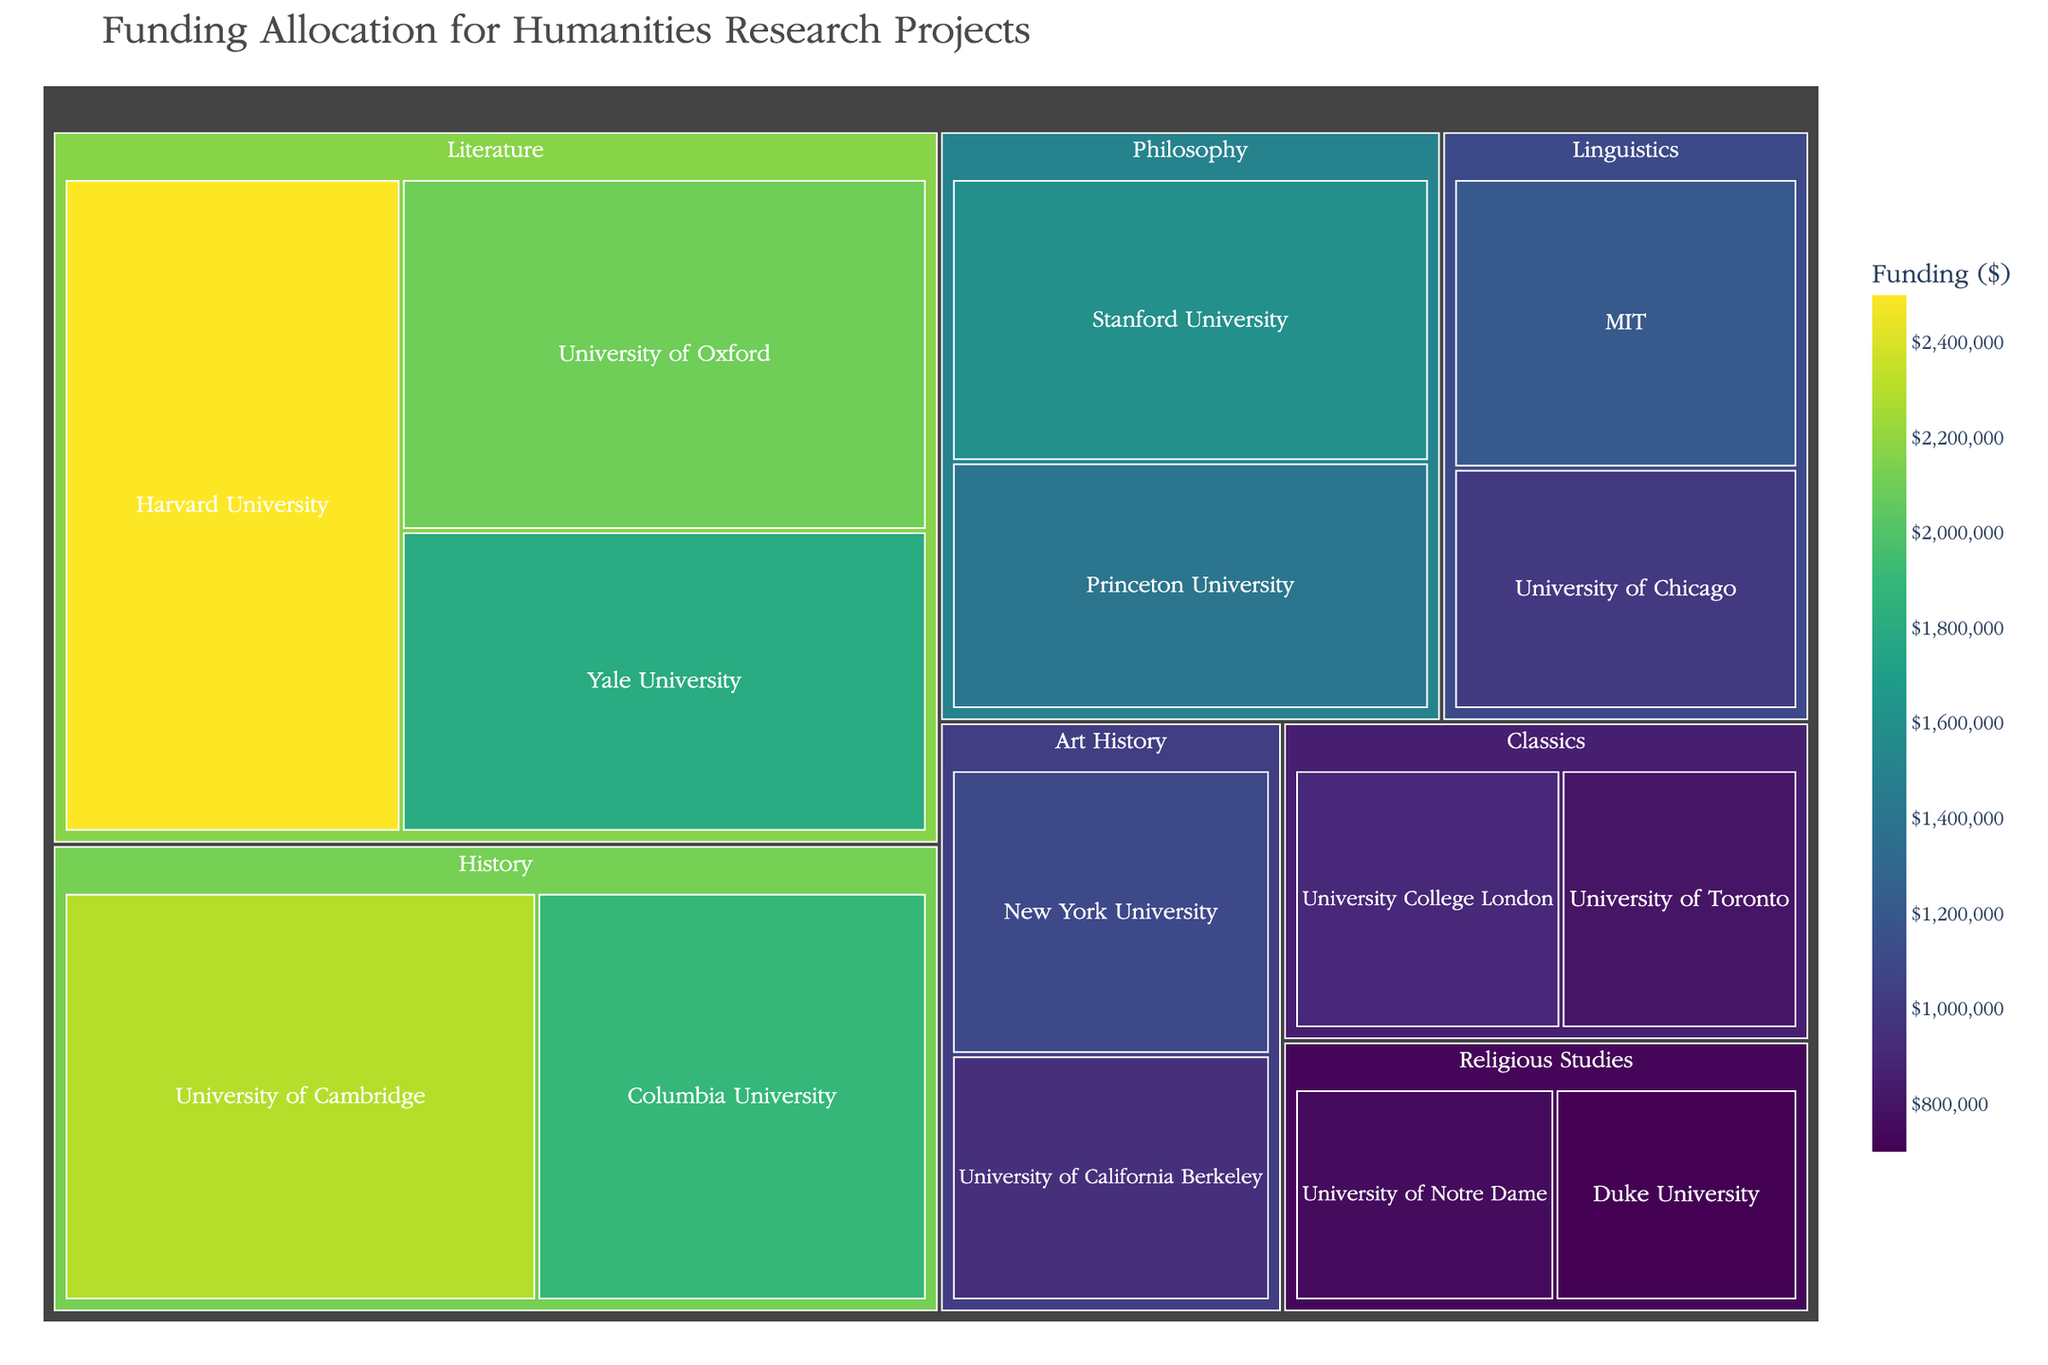Which institution received the highest funding for Literature? The highest funding for Literature can be identified by looking at the largest block under the Literature category in the treemap.
Answer: Harvard University What is the total funding allocated for Philosophy? Sum the funding amounts for Stanford University and Princeton University under the Philosophy category. 1600000 + 1400000 = 3000000
Answer: 3000000 Which subject received more funding, Art History or Linguistics? Compare the total funding amounts for Art History (New York University and University of California Berkeley) and Linguistics (MIT and University of Chicago). Art History: 1100000 + 950000 = 2050000, Linguistics: 1200000 + 1000000 = 2200000
Answer: Linguistics How many universities received funding for Religious Studies? Count the number of institutions listed under the Religious Studies category in the treemap.
Answer: 2 Which university received less funding for Classics, University College London or University of Toronto? Compare the funding amounts for University College London and University of Toronto under the Classics category. University College London: 900000, University of Toronto: 800000
Answer: University of Toronto What is the average funding allocated for History research projects? Calculate the average by summing the funding amounts for University of Cambridge and Columbia University and then divide by the number of institutions. (2300000 + 1900000) / 2 = 2100000
Answer: 2100000 What is the color axis title in the treemap? The color axis title indicates the variable represented by the color scale. From the layout customization, it shows "Funding ($)"
Answer: Funding ($) Which subject has the most institutions receiving funding? Identify the subject with the most distinct institutions listed.
Answer: Literature How much more funding does Harvard University receive for Literature compared to Yale University? Subtract the funding amount of Yale University from that of Harvard University. 2500000 - 1800000 = 700000
Answer: 700000 